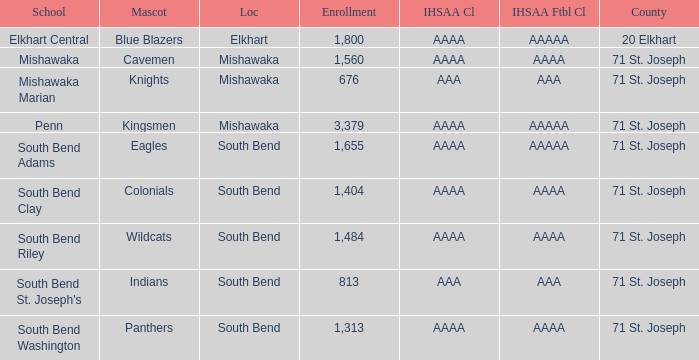What location has an enrollment greater than 1,313, and kingsmen as the mascot? Mishawaka. 